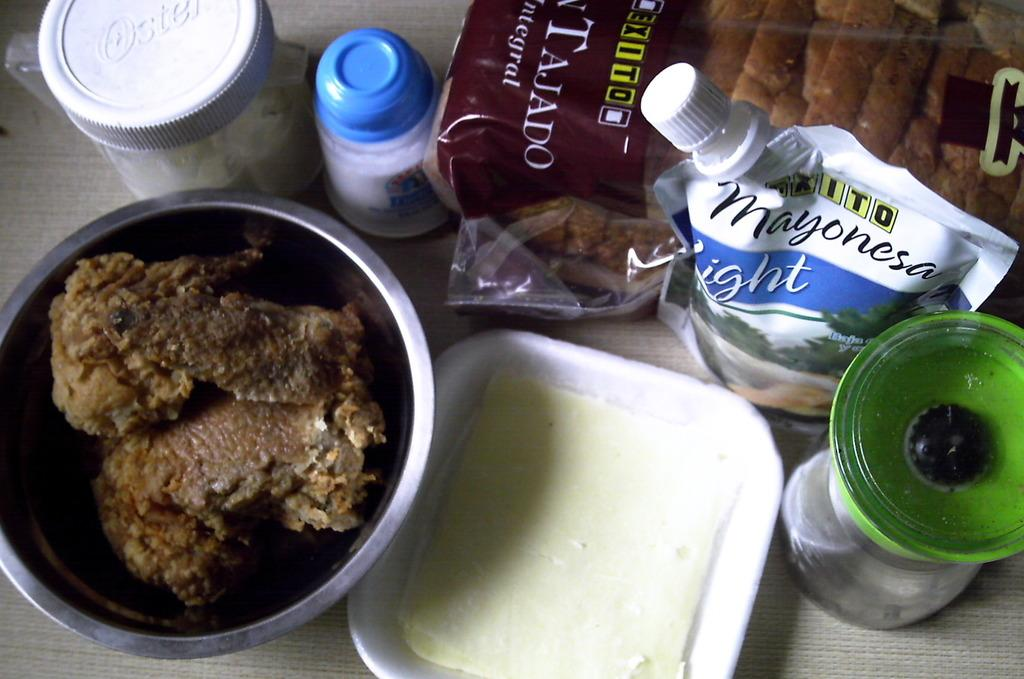<image>
Write a terse but informative summary of the picture. Ingredients for cooking, which include brad and light mayonnaise. 